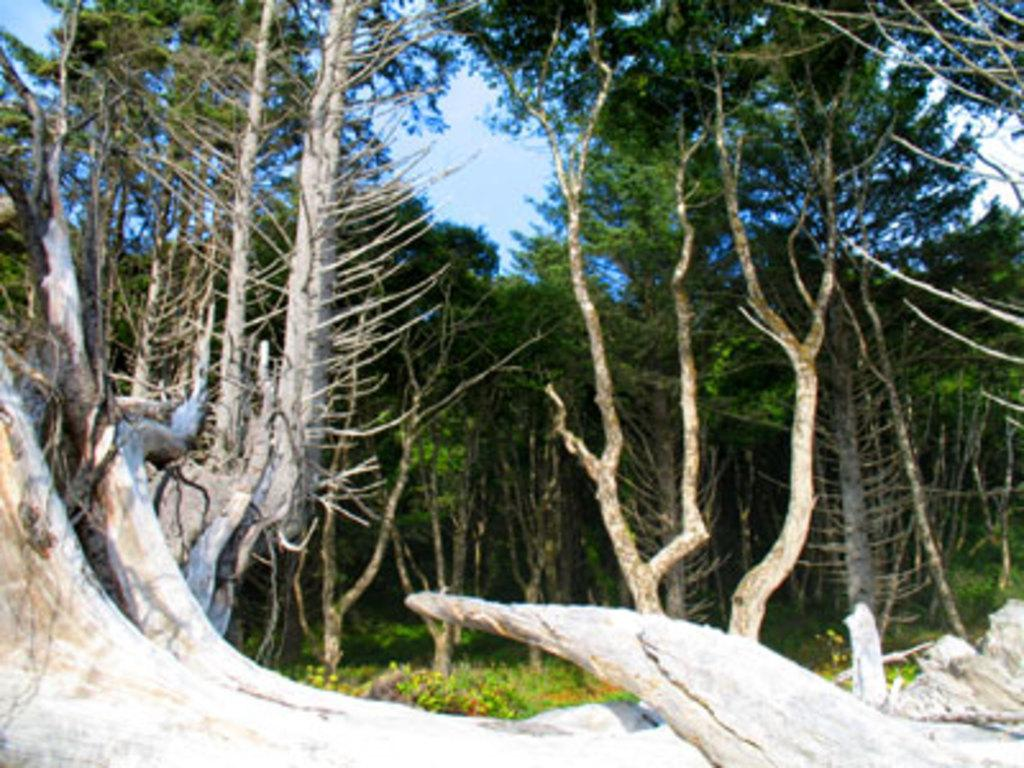What type of vegetation can be seen in the image? There are shrubs, logs, and trees in the image. What natural element is visible in the image? The sky is visible in the image. What type of pain can be seen in the image? There is no pain present in the image; it is a scene of vegetation and the sky. 